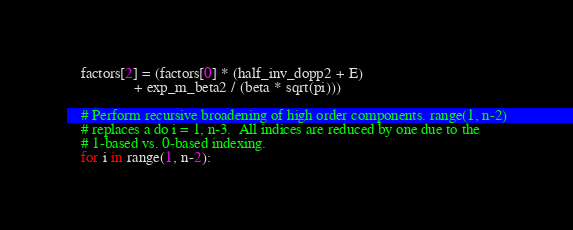<code> <loc_0><loc_0><loc_500><loc_500><_Python_>    factors[2] = (factors[0] * (half_inv_dopp2 + E)
                  + exp_m_beta2 / (beta * sqrt(pi)))

    # Perform recursive broadening of high order components. range(1, n-2)
    # replaces a do i = 1, n-3.  All indices are reduced by one due to the
    # 1-based vs. 0-based indexing.
    for i in range(1, n-2):</code> 